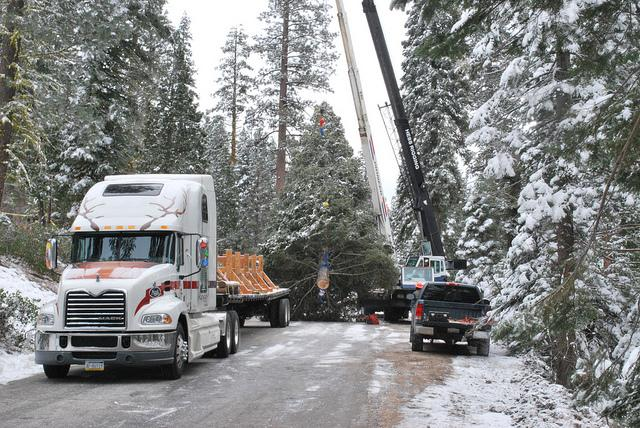What event is taking place here? tree removal 